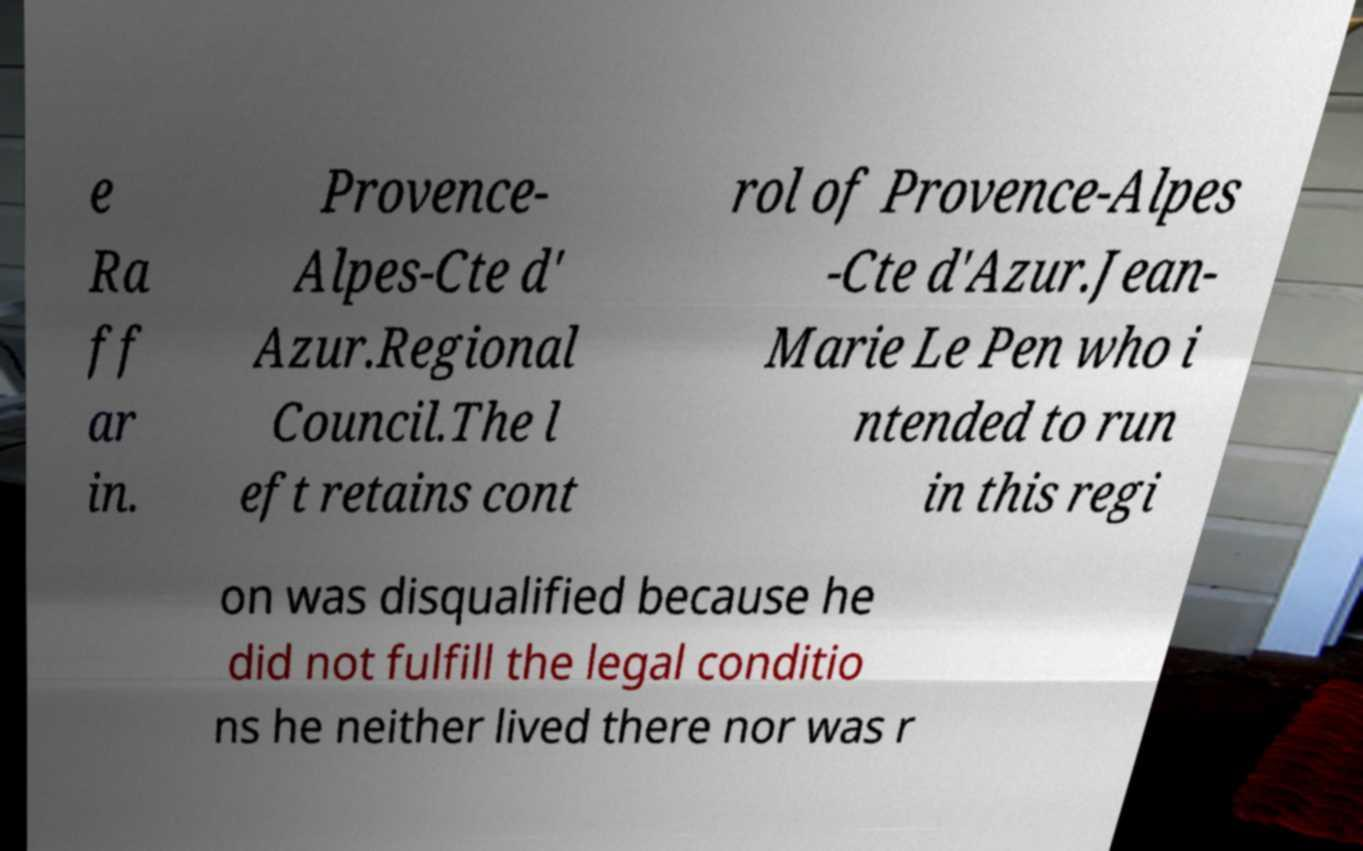There's text embedded in this image that I need extracted. Can you transcribe it verbatim? e Ra ff ar in. Provence- Alpes-Cte d' Azur.Regional Council.The l eft retains cont rol of Provence-Alpes -Cte d'Azur.Jean- Marie Le Pen who i ntended to run in this regi on was disqualified because he did not fulfill the legal conditio ns he neither lived there nor was r 